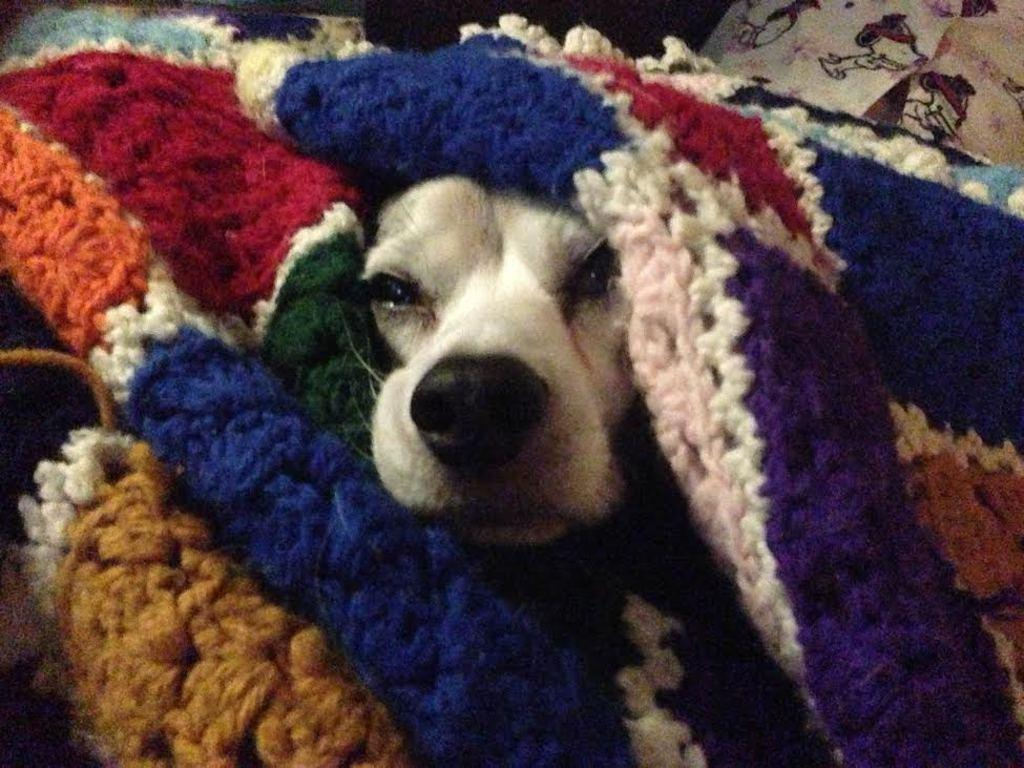What is the main subject of the image? There is a dog in the image. Where is the dog located in the image? The dog is in the center of the image. What is covering the dog in the image? The dog is covered with a blanket. What type of nut is the dog cracking open in the image? There is no nut present in the image; the dog is covered with a blanket. 